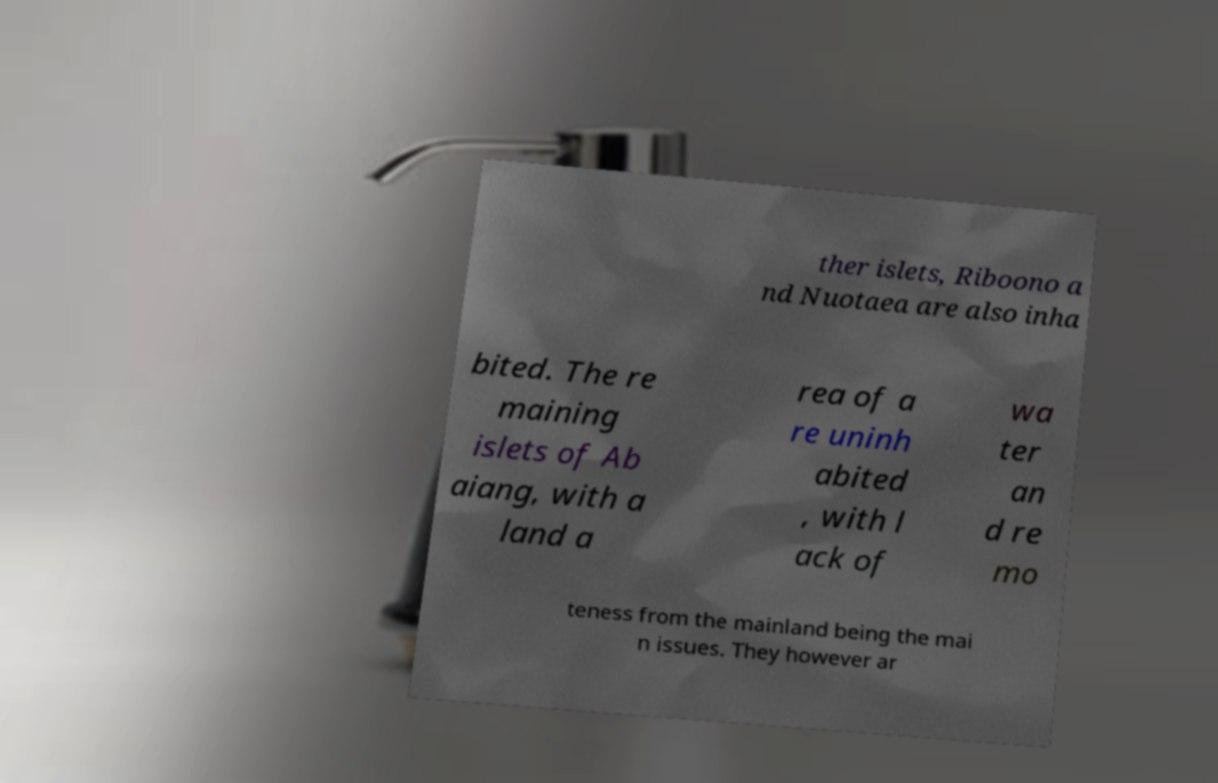Can you accurately transcribe the text from the provided image for me? ther islets, Riboono a nd Nuotaea are also inha bited. The re maining islets of Ab aiang, with a land a rea of a re uninh abited , with l ack of wa ter an d re mo teness from the mainland being the mai n issues. They however ar 